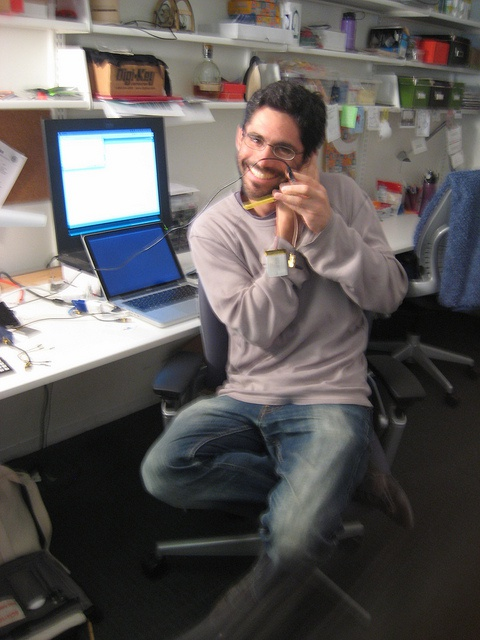Describe the objects in this image and their specific colors. I can see people in gray, black, and darkgray tones, laptop in gray, white, navy, and black tones, laptop in gray, blue, darkgray, navy, and black tones, chair in gray, black, and darkblue tones, and chair in gray, black, and darkblue tones in this image. 